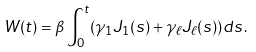Convert formula to latex. <formula><loc_0><loc_0><loc_500><loc_500>W ( t ) = \beta \int ^ { t } _ { 0 } ( \gamma _ { 1 } J _ { 1 } ( s ) + \gamma _ { \ell } J _ { \ell } ( s ) ) d s \, .</formula> 